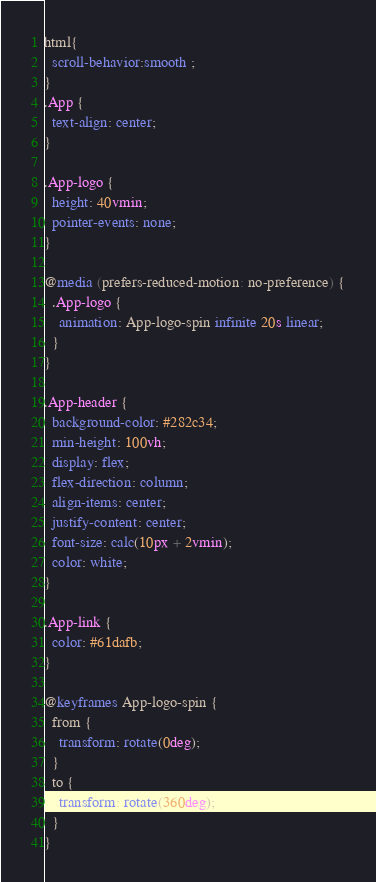<code> <loc_0><loc_0><loc_500><loc_500><_CSS_>html{
  scroll-behavior:smooth ;
}
.App {
  text-align: center;
}

.App-logo {
  height: 40vmin;
  pointer-events: none;
}

@media (prefers-reduced-motion: no-preference) {
  .App-logo {
    animation: App-logo-spin infinite 20s linear;
  }
}

.App-header {
  background-color: #282c34;
  min-height: 100vh;
  display: flex;
  flex-direction: column;
  align-items: center;
  justify-content: center;
  font-size: calc(10px + 2vmin);
  color: white;
}

.App-link {
  color: #61dafb;
}

@keyframes App-logo-spin {
  from {
    transform: rotate(0deg);
  }
  to {
    transform: rotate(360deg);
  }
}
</code> 